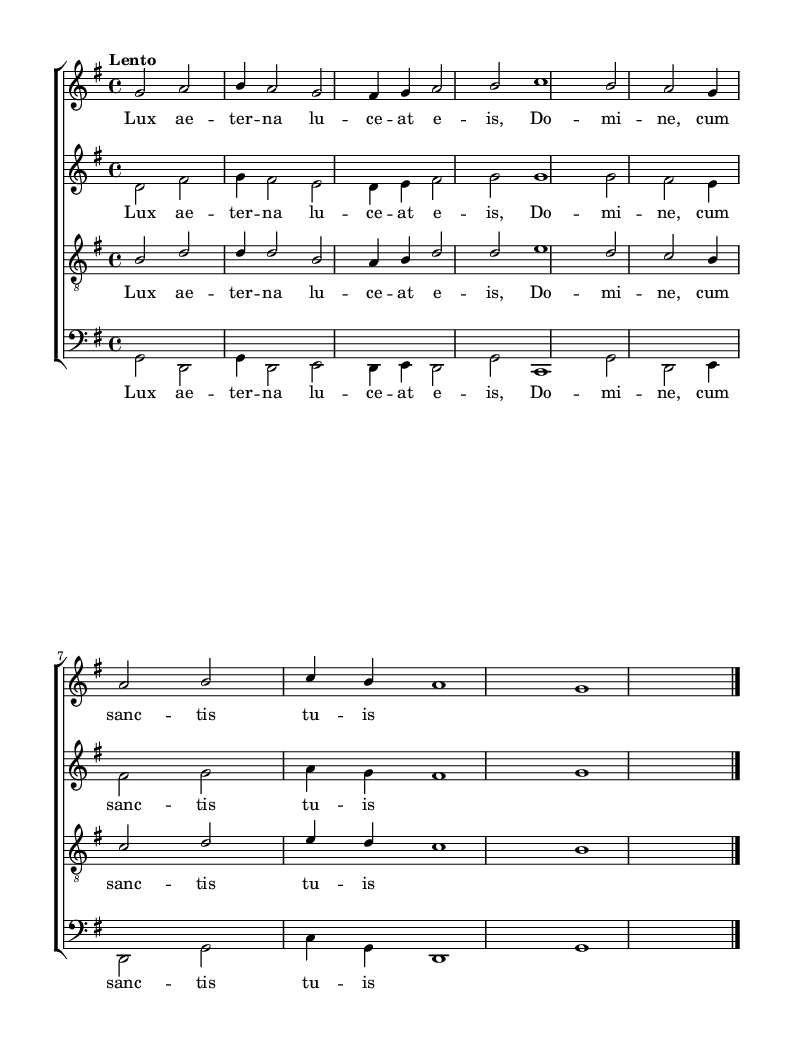What is the key signature of this music? The key signature is indicated on the left side of the staff. It shows one sharp (F#), which indicates that the piece is in G major.
Answer: G major What is the time signature of this music? The time signature is located at the beginning of the score, where it appears as 4/4, indicating four beats per measure, with the quarter note getting one beat.
Answer: 4/4 What is the tempo marking for this piece? The tempo marking "Lento" appears above the staff, indicating that the piece should be played slowly.
Answer: Lento How many voices are there in this choral work? The score includes four staves: soprano, alto, tenor, and bass, indicating that there are four distinct vocal parts.
Answer: Four Which voice has the highest pitch range? Observing the written notes, the soprano voice typically sings higher notes than the alto, tenor, or bass, making it the highest vocal line in this arrangement.
Answer: Soprano What lyrical text is repeated in all voices? The repeated text across all vocal parts is "Lux ae -- ter -- na lu -- ce -- at e -- is, Do -- mi -- ne, cum sanc -- tis tu -- is," appearing in the lyrics for soprano, alto, tenor, and bass.
Answer: Lux ae -- ter -- na lu -- ce -- at e -- is What type of harmonic texture is evident in this arrangement? This piece exhibits polyphonic texture, as it features independent melodic lines for each voice part, creating interwoven harmonies characteristic of Renaissance choral music.
Answer: Polyphonic 